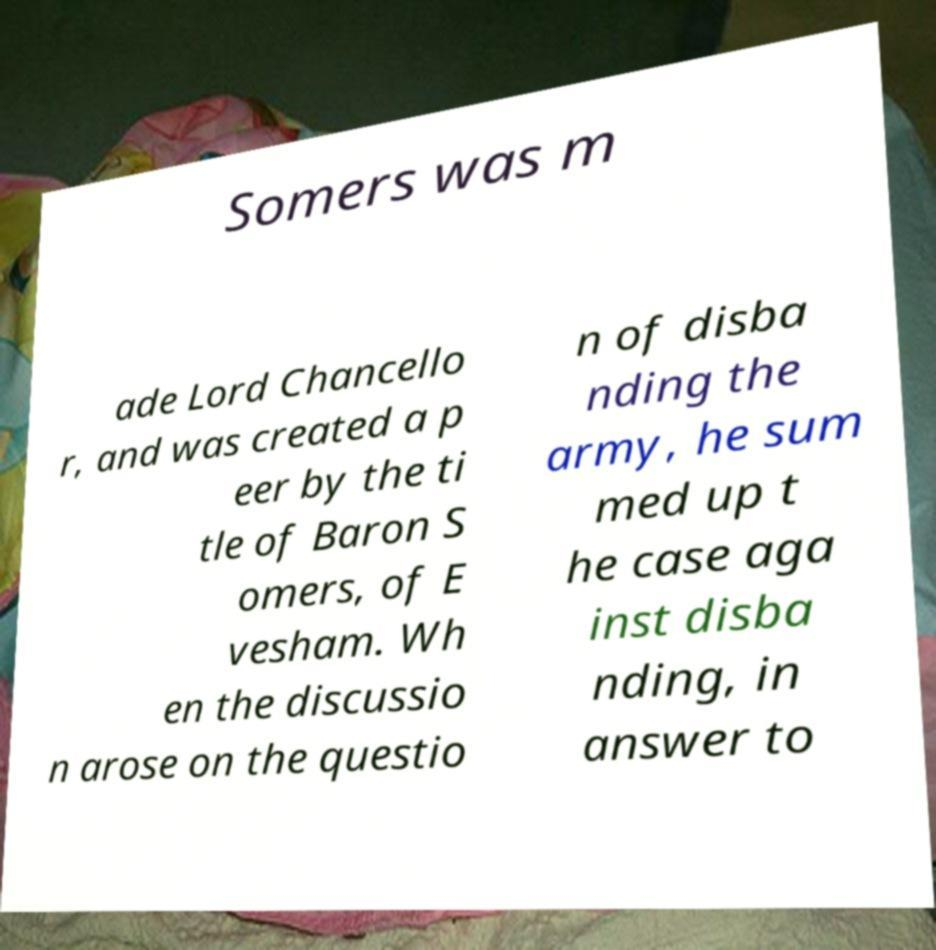There's text embedded in this image that I need extracted. Can you transcribe it verbatim? Somers was m ade Lord Chancello r, and was created a p eer by the ti tle of Baron S omers, of E vesham. Wh en the discussio n arose on the questio n of disba nding the army, he sum med up t he case aga inst disba nding, in answer to 